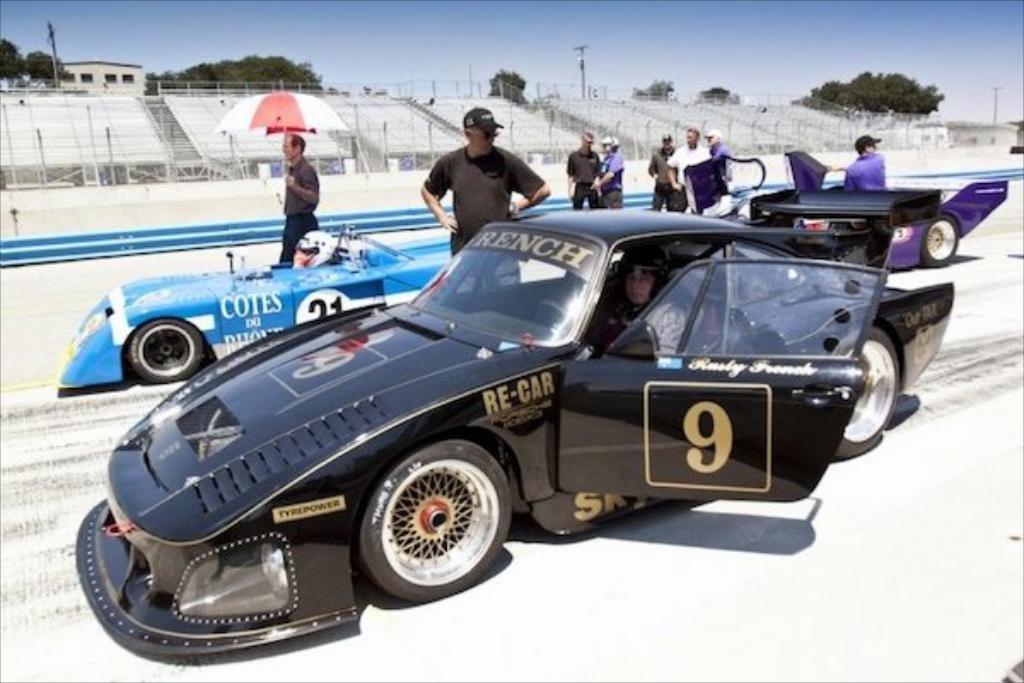Please provide a concise description of this image. In this image, we can see few vehicles on the road. Few people are inside the vehicle. Few are outside the vehicle. He we can see a person is holding an umbrella. Background we can see rods, trees, house, poles. Top of the image, there is a sky. 